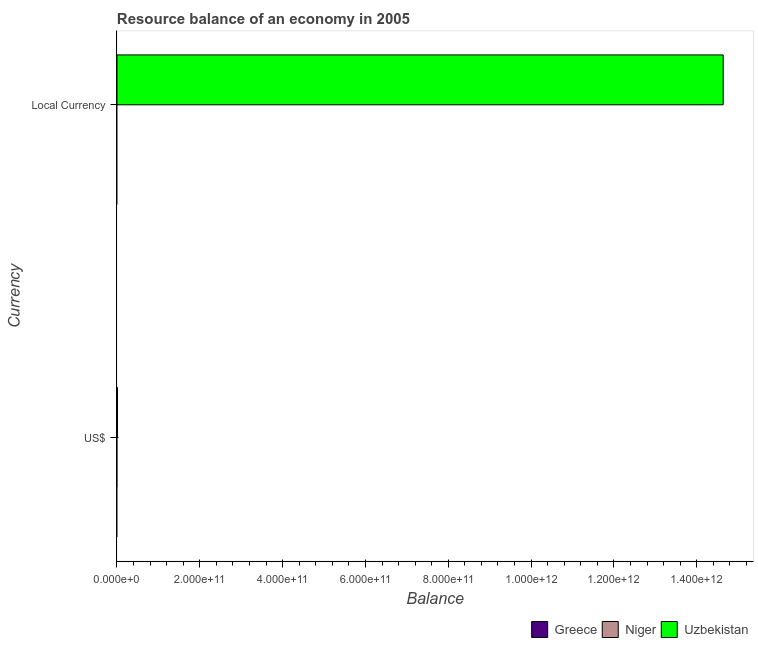How many different coloured bars are there?
Your response must be concise. 1. How many bars are there on the 1st tick from the top?
Make the answer very short. 1. What is the label of the 1st group of bars from the top?
Offer a very short reply. Local Currency. Across all countries, what is the maximum resource balance in us$?
Your answer should be very brief. 1.32e+09. In which country was the resource balance in us$ maximum?
Offer a very short reply. Uzbekistan. What is the total resource balance in us$ in the graph?
Your response must be concise. 1.32e+09. What is the difference between the resource balance in constant us$ in Uzbekistan and the resource balance in us$ in Greece?
Your response must be concise. 1.46e+12. What is the average resource balance in constant us$ per country?
Keep it short and to the point. 4.88e+11. What is the difference between the resource balance in us$ and resource balance in constant us$ in Uzbekistan?
Provide a succinct answer. -1.46e+12. How many bars are there?
Offer a very short reply. 2. What is the difference between two consecutive major ticks on the X-axis?
Offer a terse response. 2.00e+11. Are the values on the major ticks of X-axis written in scientific E-notation?
Your response must be concise. Yes. Does the graph contain any zero values?
Give a very brief answer. Yes. Does the graph contain grids?
Keep it short and to the point. No. How are the legend labels stacked?
Offer a terse response. Horizontal. What is the title of the graph?
Make the answer very short. Resource balance of an economy in 2005. What is the label or title of the X-axis?
Provide a short and direct response. Balance. What is the label or title of the Y-axis?
Give a very brief answer. Currency. What is the Balance of Greece in US$?
Make the answer very short. 0. What is the Balance in Niger in US$?
Offer a very short reply. 0. What is the Balance of Uzbekistan in US$?
Your response must be concise. 1.32e+09. What is the Balance in Niger in Local Currency?
Offer a terse response. 0. What is the Balance in Uzbekistan in Local Currency?
Ensure brevity in your answer.  1.46e+12. Across all Currency, what is the maximum Balance of Uzbekistan?
Keep it short and to the point. 1.46e+12. Across all Currency, what is the minimum Balance in Uzbekistan?
Provide a short and direct response. 1.32e+09. What is the total Balance in Niger in the graph?
Ensure brevity in your answer.  0. What is the total Balance in Uzbekistan in the graph?
Provide a succinct answer. 1.47e+12. What is the difference between the Balance of Uzbekistan in US$ and that in Local Currency?
Provide a short and direct response. -1.46e+12. What is the average Balance in Uzbekistan per Currency?
Provide a succinct answer. 7.33e+11. What is the ratio of the Balance in Uzbekistan in US$ to that in Local Currency?
Provide a succinct answer. 0. What is the difference between the highest and the second highest Balance of Uzbekistan?
Provide a short and direct response. 1.46e+12. What is the difference between the highest and the lowest Balance of Uzbekistan?
Ensure brevity in your answer.  1.46e+12. 